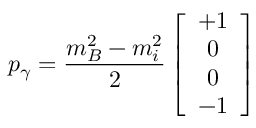<formula> <loc_0><loc_0><loc_500><loc_500>p _ { \gamma } = { \frac { m _ { B } ^ { 2 } - m _ { i } ^ { 2 } } { 2 } } \left [ \begin{array} { c } { + 1 } \\ { 0 } \\ { 0 } \\ { - 1 } \end{array} \right ]</formula> 